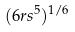Convert formula to latex. <formula><loc_0><loc_0><loc_500><loc_500>( 6 r s ^ { 5 } ) ^ { 1 / 6 }</formula> 